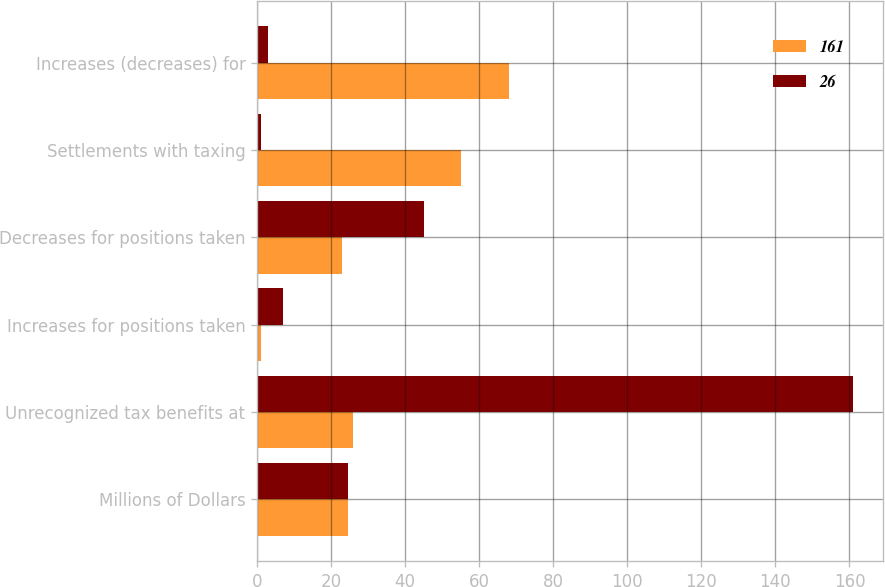Convert chart to OTSL. <chart><loc_0><loc_0><loc_500><loc_500><stacked_bar_chart><ecel><fcel>Millions of Dollars<fcel>Unrecognized tax benefits at<fcel>Increases for positions taken<fcel>Decreases for positions taken<fcel>Settlements with taxing<fcel>Increases (decreases) for<nl><fcel>161<fcel>24.5<fcel>26<fcel>1<fcel>23<fcel>55<fcel>68<nl><fcel>26<fcel>24.5<fcel>161<fcel>7<fcel>45<fcel>1<fcel>3<nl></chart> 